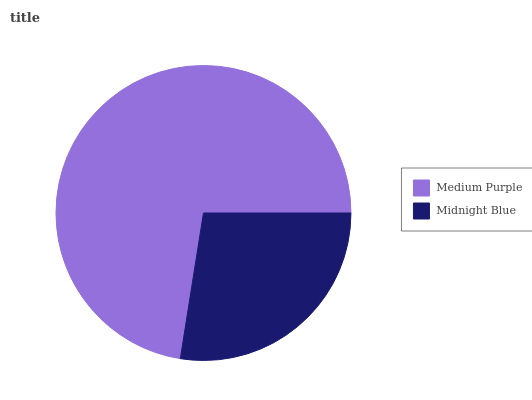Is Midnight Blue the minimum?
Answer yes or no. Yes. Is Medium Purple the maximum?
Answer yes or no. Yes. Is Midnight Blue the maximum?
Answer yes or no. No. Is Medium Purple greater than Midnight Blue?
Answer yes or no. Yes. Is Midnight Blue less than Medium Purple?
Answer yes or no. Yes. Is Midnight Blue greater than Medium Purple?
Answer yes or no. No. Is Medium Purple less than Midnight Blue?
Answer yes or no. No. Is Medium Purple the high median?
Answer yes or no. Yes. Is Midnight Blue the low median?
Answer yes or no. Yes. Is Midnight Blue the high median?
Answer yes or no. No. Is Medium Purple the low median?
Answer yes or no. No. 